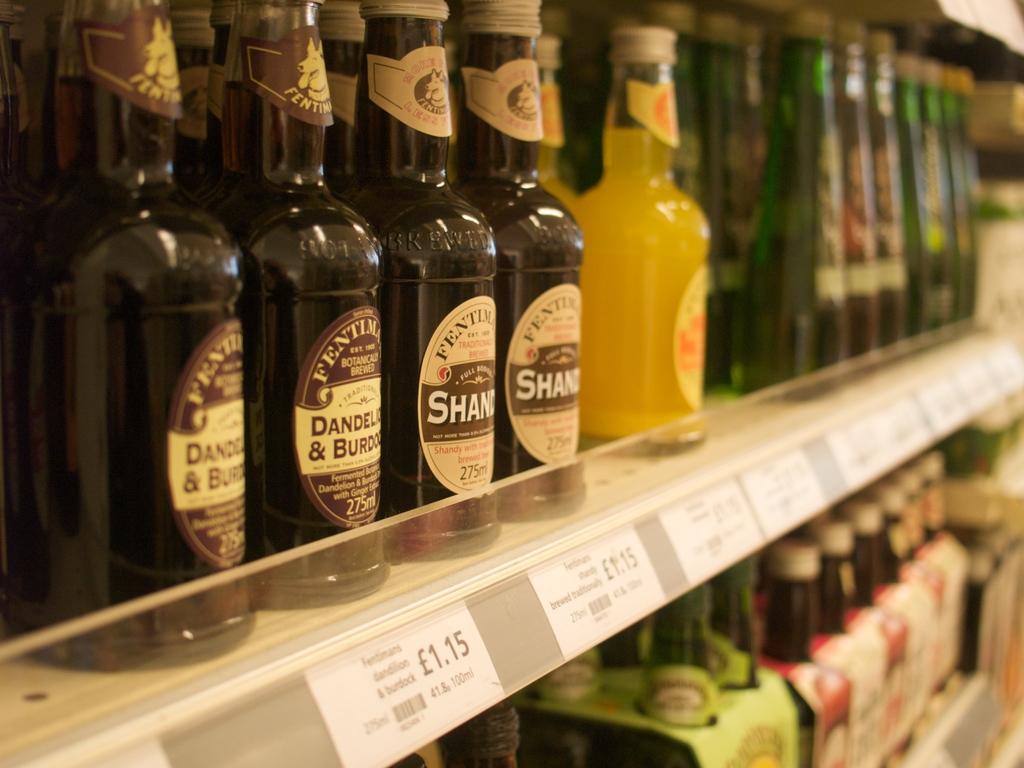How much do the two on the left cost?
Provide a short and direct response. 1.15. 